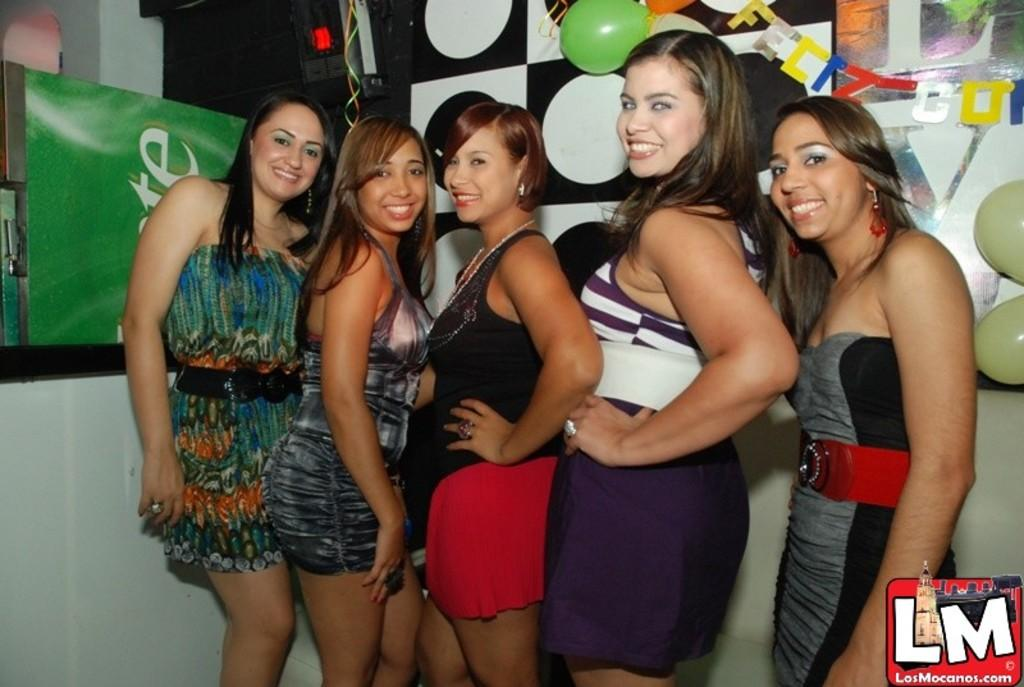What are the people in the image doing? The people in the image are standing and smiling. What can be seen in the image besides the people? There are balloons, a machine, and other objects in the image. What is the background of the image like? There is a wall and a pillar in the image. What type of clouds can be seen in the image? There are no clouds visible in the image. Is there a flame present in the image? There is no flame present in the image. 